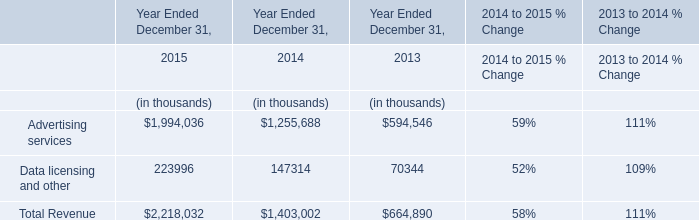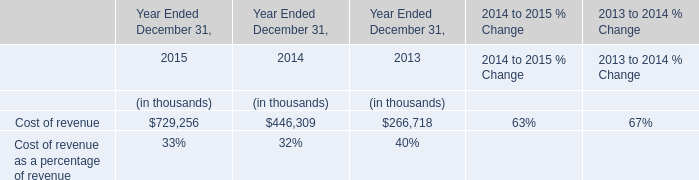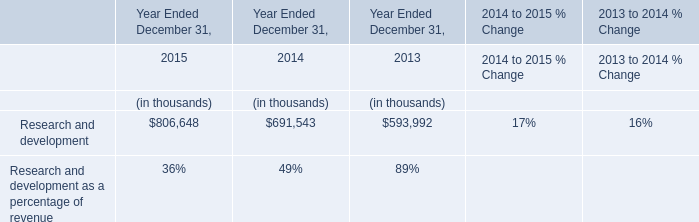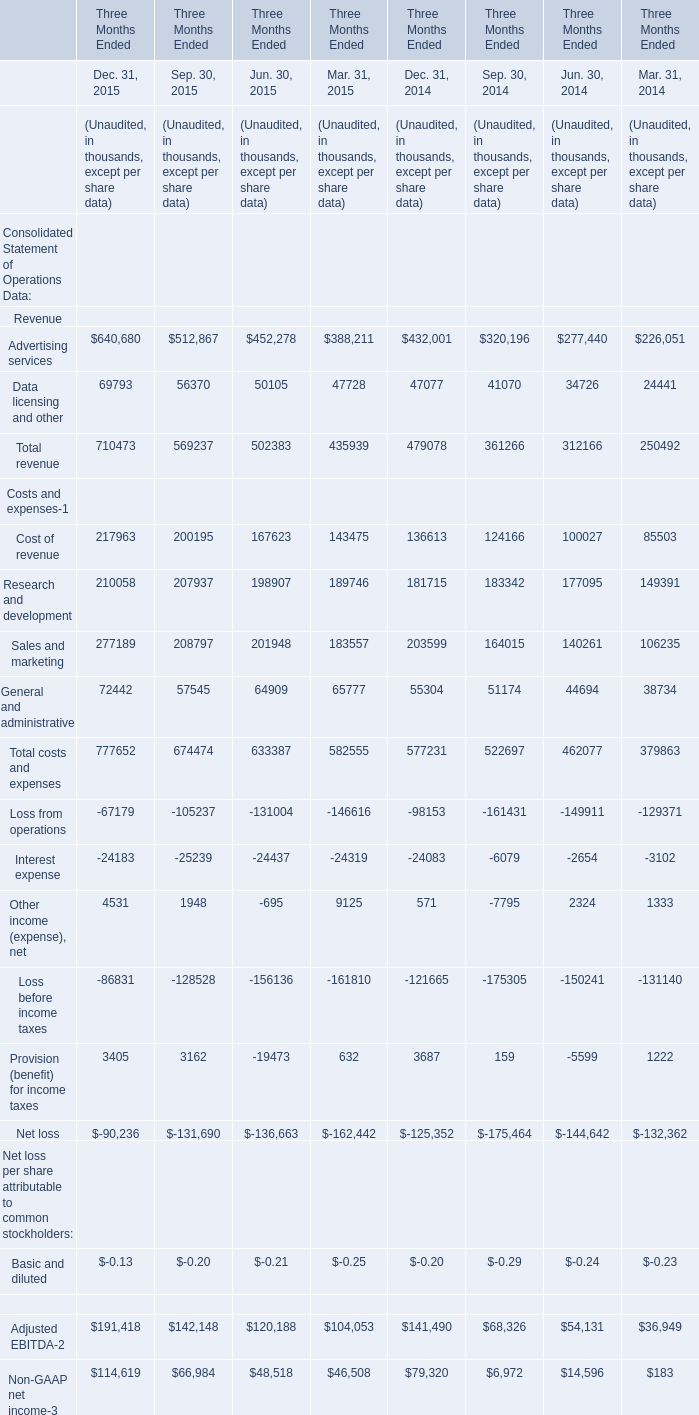Does the value of Advertising services in Dec. 31, 2014 greater than that in Dec. 31, 2015? 
Answer: No. 